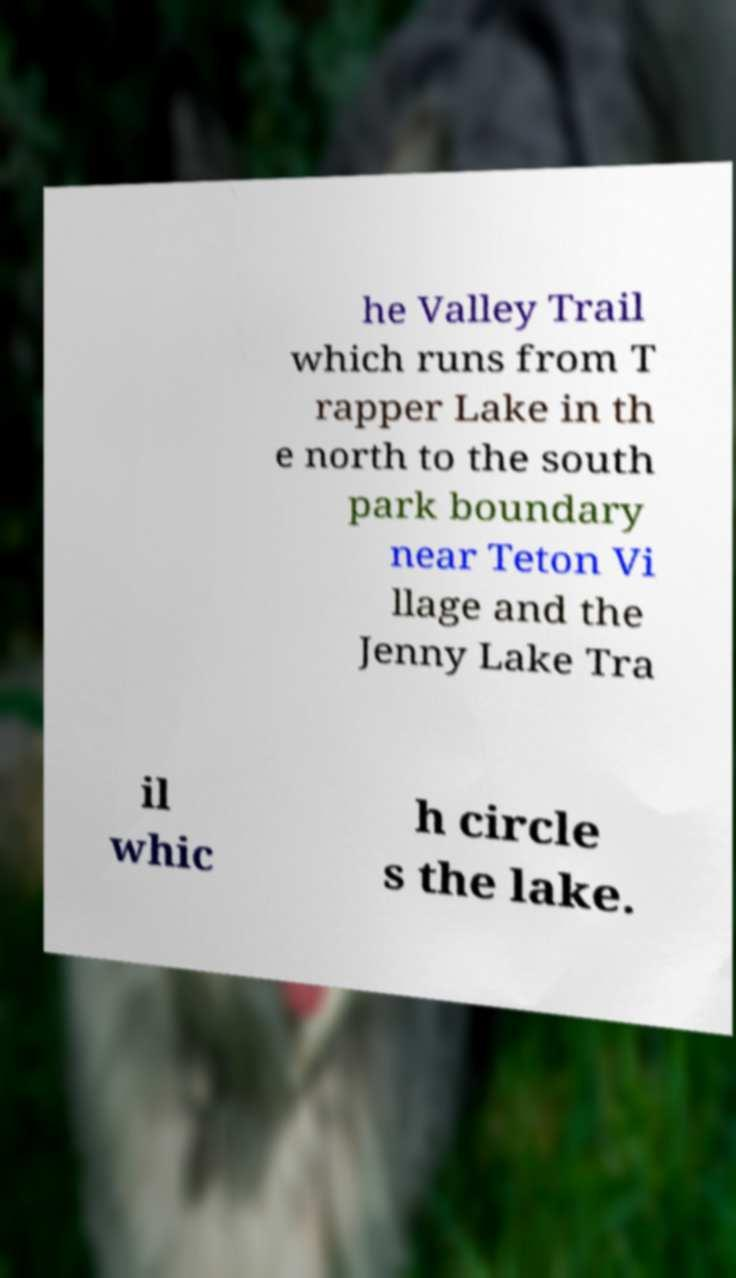What messages or text are displayed in this image? I need them in a readable, typed format. he Valley Trail which runs from T rapper Lake in th e north to the south park boundary near Teton Vi llage and the Jenny Lake Tra il whic h circle s the lake. 